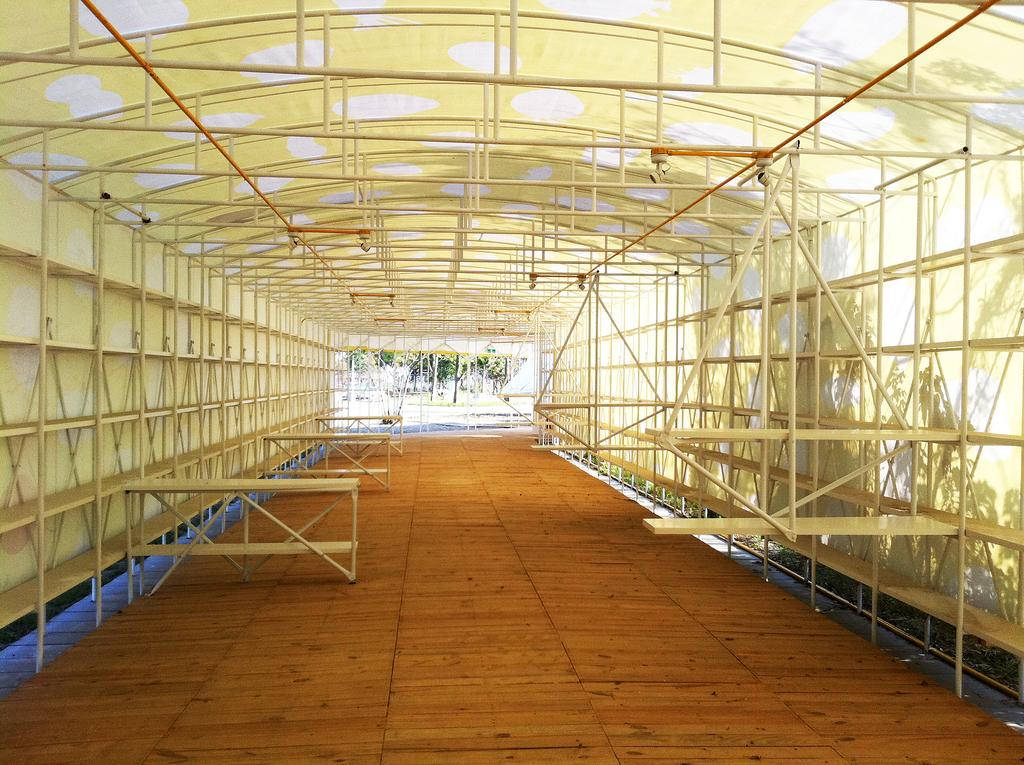What type of seating is visible in the image? There are benches in the image. What material are the rods made of in the image? The rods in the image are made of metal. What type of structure is present in the image? There is a shed in the image. What type of vegetation is visible in the image? There are trees in the image. What type of vertical structures are present in the image? There are poles in the image. Can you determine the time of day the image was taken? The image was likely taken during the day, as there is sufficient light to see the details clearly. How much honey is being consumed by the boys in the image? There are no boys or honey present in the image. What type of injury is visible on the wrist of the person in the image? There is no person or wrist injury present in the image. 